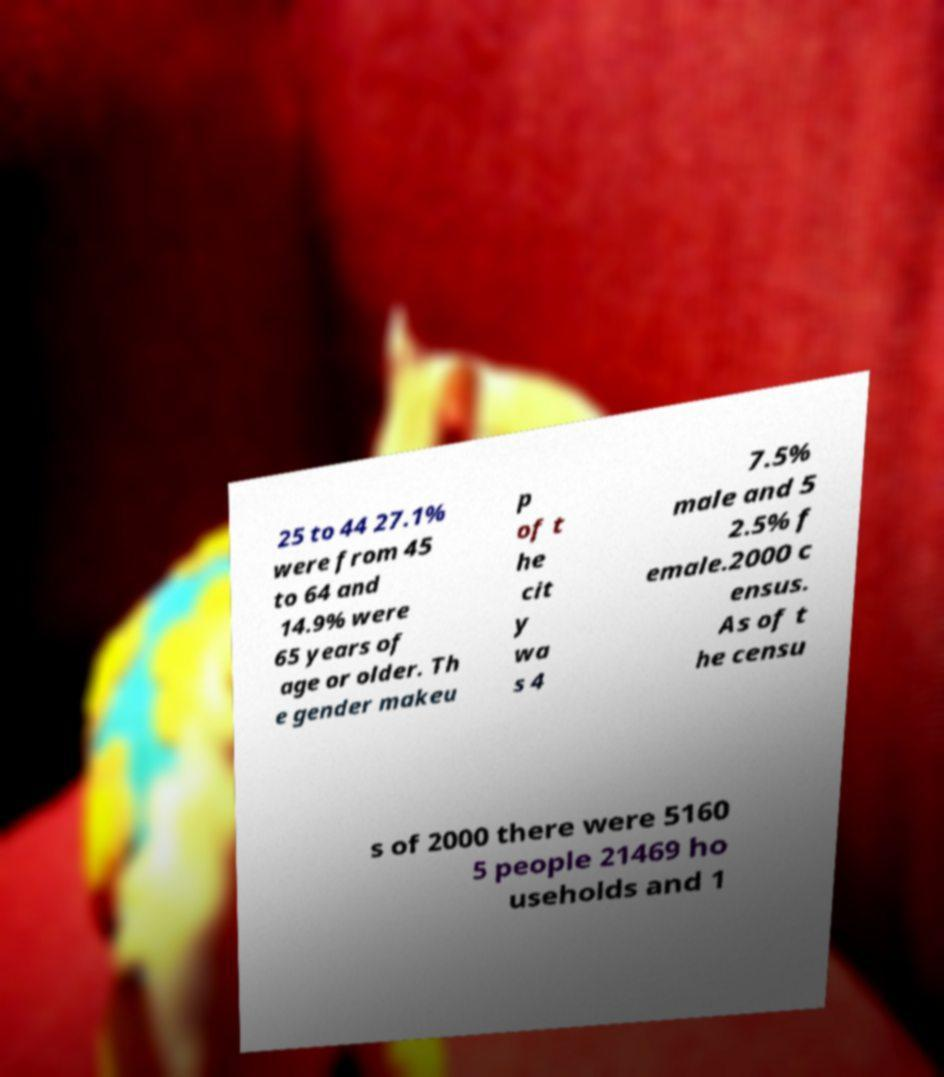There's text embedded in this image that I need extracted. Can you transcribe it verbatim? 25 to 44 27.1% were from 45 to 64 and 14.9% were 65 years of age or older. Th e gender makeu p of t he cit y wa s 4 7.5% male and 5 2.5% f emale.2000 c ensus. As of t he censu s of 2000 there were 5160 5 people 21469 ho useholds and 1 